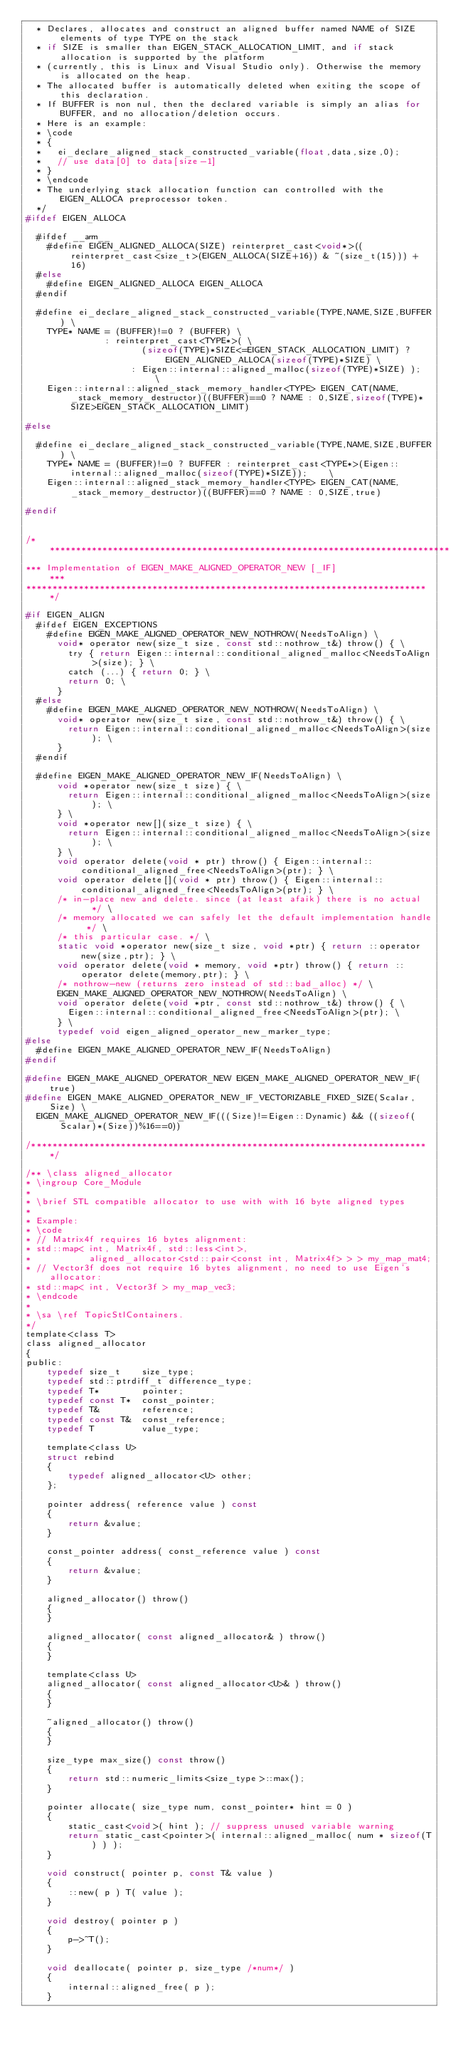Convert code to text. <code><loc_0><loc_0><loc_500><loc_500><_C_>  * Declares, allocates and construct an aligned buffer named NAME of SIZE elements of type TYPE on the stack
  * if SIZE is smaller than EIGEN_STACK_ALLOCATION_LIMIT, and if stack allocation is supported by the platform
  * (currently, this is Linux and Visual Studio only). Otherwise the memory is allocated on the heap.
  * The allocated buffer is automatically deleted when exiting the scope of this declaration.
  * If BUFFER is non nul, then the declared variable is simply an alias for BUFFER, and no allocation/deletion occurs.
  * Here is an example:
  * \code
  * {
  *   ei_declare_aligned_stack_constructed_variable(float,data,size,0);
  *   // use data[0] to data[size-1]
  * }
  * \endcode
  * The underlying stack allocation function can controlled with the EIGEN_ALLOCA preprocessor token.
  */
#ifdef EIGEN_ALLOCA

  #ifdef __arm__
    #define EIGEN_ALIGNED_ALLOCA(SIZE) reinterpret_cast<void*>((reinterpret_cast<size_t>(EIGEN_ALLOCA(SIZE+16)) & ~(size_t(15))) + 16)
  #else
    #define EIGEN_ALIGNED_ALLOCA EIGEN_ALLOCA
  #endif

  #define ei_declare_aligned_stack_constructed_variable(TYPE,NAME,SIZE,BUFFER) \
    TYPE* NAME = (BUFFER)!=0 ? (BUFFER) \
               : reinterpret_cast<TYPE*>( \
                      (sizeof(TYPE)*SIZE<=EIGEN_STACK_ALLOCATION_LIMIT) ? EIGEN_ALIGNED_ALLOCA(sizeof(TYPE)*SIZE) \
                    : Eigen::internal::aligned_malloc(sizeof(TYPE)*SIZE) );  \
    Eigen::internal::aligned_stack_memory_handler<TYPE> EIGEN_CAT(NAME,_stack_memory_destructor)((BUFFER)==0 ? NAME : 0,SIZE,sizeof(TYPE)*SIZE>EIGEN_STACK_ALLOCATION_LIMIT)

#else

  #define ei_declare_aligned_stack_constructed_variable(TYPE,NAME,SIZE,BUFFER) \
    TYPE* NAME = (BUFFER)!=0 ? BUFFER : reinterpret_cast<TYPE*>(Eigen::internal::aligned_malloc(sizeof(TYPE)*SIZE));    \
    Eigen::internal::aligned_stack_memory_handler<TYPE> EIGEN_CAT(NAME,_stack_memory_destructor)((BUFFER)==0 ? NAME : 0,SIZE,true)
    
#endif


/*****************************************************************************
*** Implementation of EIGEN_MAKE_ALIGNED_OPERATOR_NEW [_IF]                ***
*****************************************************************************/

#if EIGEN_ALIGN
  #ifdef EIGEN_EXCEPTIONS
    #define EIGEN_MAKE_ALIGNED_OPERATOR_NEW_NOTHROW(NeedsToAlign) \
      void* operator new(size_t size, const std::nothrow_t&) throw() { \
        try { return Eigen::internal::conditional_aligned_malloc<NeedsToAlign>(size); } \
        catch (...) { return 0; } \
        return 0; \
      }
  #else
    #define EIGEN_MAKE_ALIGNED_OPERATOR_NEW_NOTHROW(NeedsToAlign) \
      void* operator new(size_t size, const std::nothrow_t&) throw() { \
        return Eigen::internal::conditional_aligned_malloc<NeedsToAlign>(size); \
      }
  #endif

  #define EIGEN_MAKE_ALIGNED_OPERATOR_NEW_IF(NeedsToAlign) \
      void *operator new(size_t size) { \
        return Eigen::internal::conditional_aligned_malloc<NeedsToAlign>(size); \
      } \
      void *operator new[](size_t size) { \
        return Eigen::internal::conditional_aligned_malloc<NeedsToAlign>(size); \
      } \
      void operator delete(void * ptr) throw() { Eigen::internal::conditional_aligned_free<NeedsToAlign>(ptr); } \
      void operator delete[](void * ptr) throw() { Eigen::internal::conditional_aligned_free<NeedsToAlign>(ptr); } \
      /* in-place new and delete. since (at least afaik) there is no actual   */ \
      /* memory allocated we can safely let the default implementation handle */ \
      /* this particular case. */ \
      static void *operator new(size_t size, void *ptr) { return ::operator new(size,ptr); } \
      void operator delete(void * memory, void *ptr) throw() { return ::operator delete(memory,ptr); } \
      /* nothrow-new (returns zero instead of std::bad_alloc) */ \
      EIGEN_MAKE_ALIGNED_OPERATOR_NEW_NOTHROW(NeedsToAlign) \
      void operator delete(void *ptr, const std::nothrow_t&) throw() { \
        Eigen::internal::conditional_aligned_free<NeedsToAlign>(ptr); \
      } \
      typedef void eigen_aligned_operator_new_marker_type;
#else
  #define EIGEN_MAKE_ALIGNED_OPERATOR_NEW_IF(NeedsToAlign)
#endif

#define EIGEN_MAKE_ALIGNED_OPERATOR_NEW EIGEN_MAKE_ALIGNED_OPERATOR_NEW_IF(true)
#define EIGEN_MAKE_ALIGNED_OPERATOR_NEW_IF_VECTORIZABLE_FIXED_SIZE(Scalar,Size) \
  EIGEN_MAKE_ALIGNED_OPERATOR_NEW_IF(((Size)!=Eigen::Dynamic) && ((sizeof(Scalar)*(Size))%16==0))

/****************************************************************************/

/** \class aligned_allocator
* \ingroup Core_Module
*
* \brief STL compatible allocator to use with with 16 byte aligned types
*
* Example:
* \code
* // Matrix4f requires 16 bytes alignment:
* std::map< int, Matrix4f, std::less<int>, 
*           aligned_allocator<std::pair<const int, Matrix4f> > > my_map_mat4;
* // Vector3f does not require 16 bytes alignment, no need to use Eigen's allocator:
* std::map< int, Vector3f > my_map_vec3;
* \endcode
*
* \sa \ref TopicStlContainers.
*/
template<class T>
class aligned_allocator
{
public:
    typedef size_t    size_type;
    typedef std::ptrdiff_t difference_type;
    typedef T*        pointer;
    typedef const T*  const_pointer;
    typedef T&        reference;
    typedef const T&  const_reference;
    typedef T         value_type;

    template<class U>
    struct rebind
    {
        typedef aligned_allocator<U> other;
    };

    pointer address( reference value ) const
    {
        return &value;
    }

    const_pointer address( const_reference value ) const
    {
        return &value;
    }

    aligned_allocator() throw()
    {
    }

    aligned_allocator( const aligned_allocator& ) throw()
    {
    }

    template<class U>
    aligned_allocator( const aligned_allocator<U>& ) throw()
    {
    }

    ~aligned_allocator() throw()
    {
    }

    size_type max_size() const throw()
    {
        return std::numeric_limits<size_type>::max();
    }

    pointer allocate( size_type num, const_pointer* hint = 0 )
    {
        static_cast<void>( hint ); // suppress unused variable warning
        return static_cast<pointer>( internal::aligned_malloc( num * sizeof(T) ) );
    }

    void construct( pointer p, const T& value )
    {
        ::new( p ) T( value );
    }

    void destroy( pointer p )
    {
        p->~T();
    }

    void deallocate( pointer p, size_type /*num*/ )
    {
        internal::aligned_free( p );
    }
</code> 